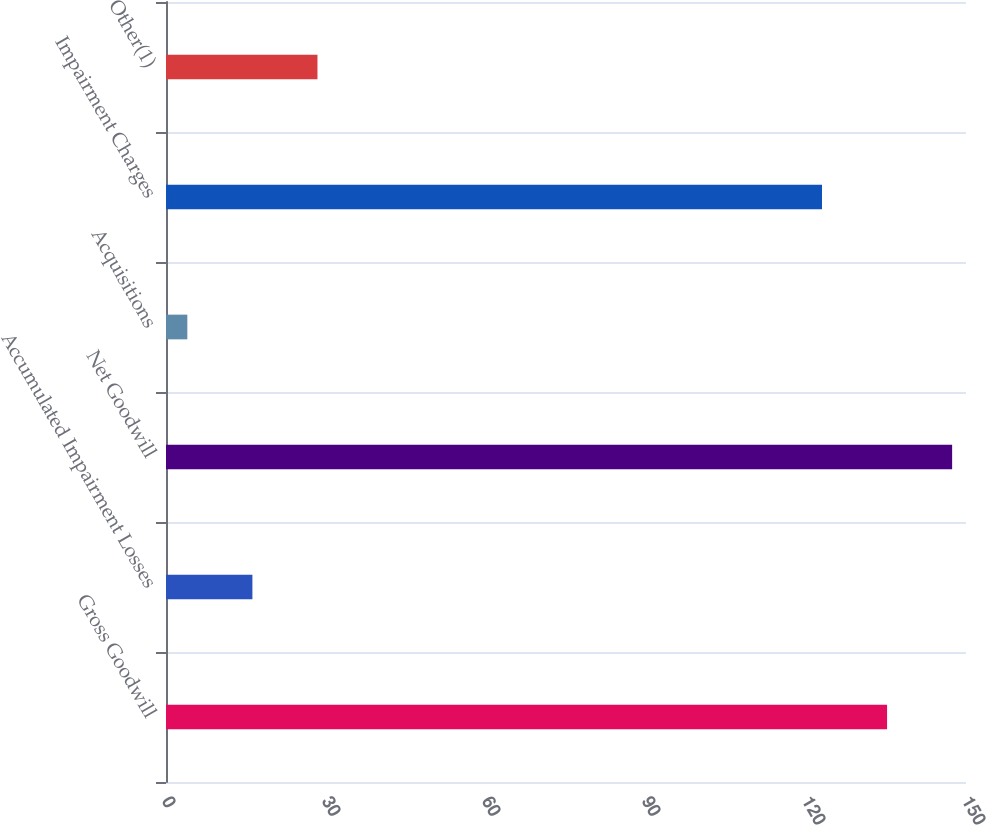Convert chart. <chart><loc_0><loc_0><loc_500><loc_500><bar_chart><fcel>Gross Goodwill<fcel>Accumulated Impairment Losses<fcel>Net Goodwill<fcel>Acquisitions<fcel>Impairment Charges<fcel>Other(1)<nl><fcel>135.2<fcel>16.2<fcel>147.4<fcel>4<fcel>123<fcel>28.4<nl></chart> 